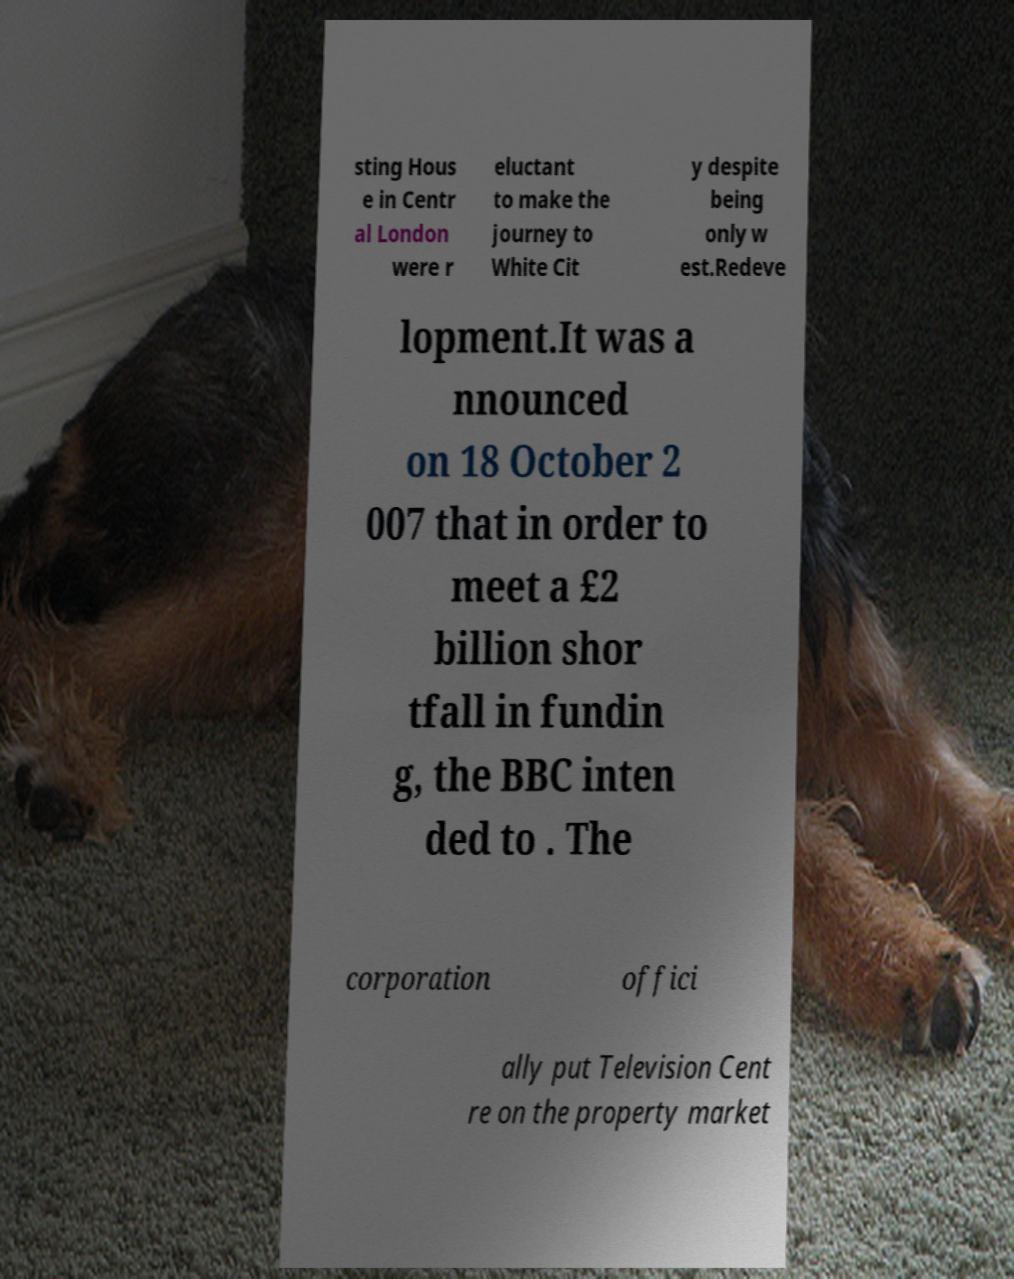Can you read and provide the text displayed in the image?This photo seems to have some interesting text. Can you extract and type it out for me? sting Hous e in Centr al London were r eluctant to make the journey to White Cit y despite being only w est.Redeve lopment.It was a nnounced on 18 October 2 007 that in order to meet a £2 billion shor tfall in fundin g, the BBC inten ded to . The corporation offici ally put Television Cent re on the property market 